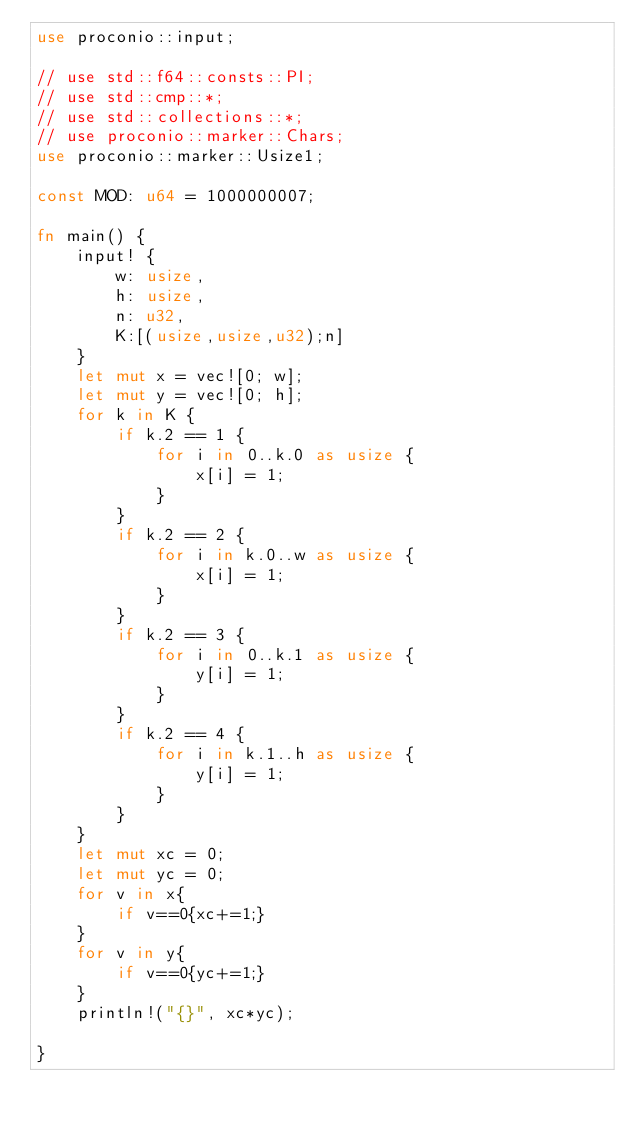<code> <loc_0><loc_0><loc_500><loc_500><_Rust_>use proconio::input;

// use std::f64::consts::PI;
// use std::cmp::*;
// use std::collections::*;
// use proconio::marker::Chars;
use proconio::marker::Usize1;

const MOD: u64 = 1000000007;

fn main() {
    input! {
        w: usize,
        h: usize,
        n: u32,
        K:[(usize,usize,u32);n]
    }
    let mut x = vec![0; w];
    let mut y = vec![0; h];
    for k in K {
        if k.2 == 1 {
            for i in 0..k.0 as usize {
                x[i] = 1;
            }
        }
        if k.2 == 2 {
            for i in k.0..w as usize {
                x[i] = 1;
            }
        }
        if k.2 == 3 {
            for i in 0..k.1 as usize {
                y[i] = 1;
            }
        }
        if k.2 == 4 {
            for i in k.1..h as usize {
                y[i] = 1;
            }
        }
    }
    let mut xc = 0;
    let mut yc = 0;
    for v in x{
        if v==0{xc+=1;}
    }
    for v in y{
        if v==0{yc+=1;}
    }
    println!("{}", xc*yc);

}
</code> 